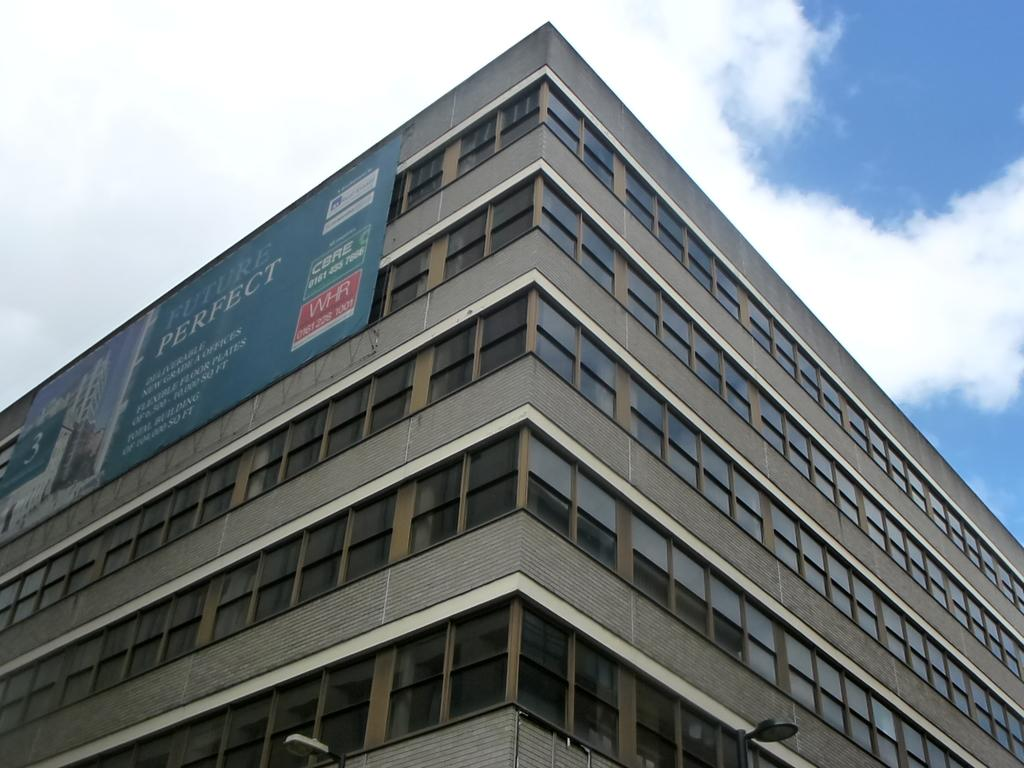What type of building is depicted in the image? There is a very big building with glass windows in the image. Can you describe any additional features on the building? Yes, there is a banner onner on the left side of the building. What is the weather like in the image? The sky is cloudy in the image. What type of jeans is the building wearing in the image? Buildings do not wear jeans, as they are inanimate objects. 